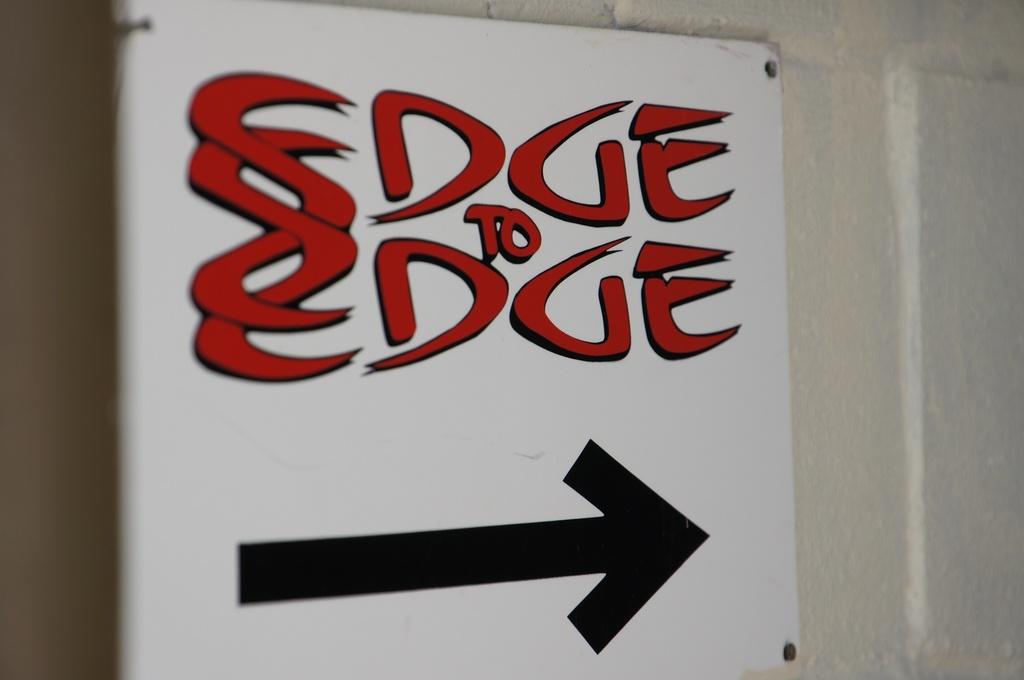What does this tell you?
Offer a terse response. Edge to edge. 